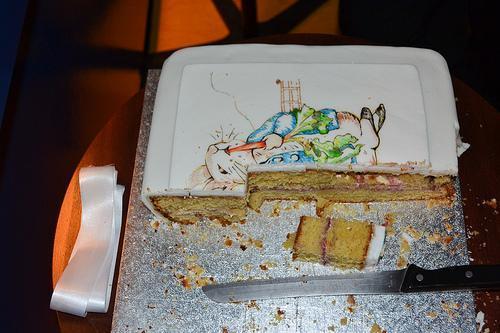How many layers is this cake?
Give a very brief answer. 2. How many rabbits are visible?
Give a very brief answer. 1. 